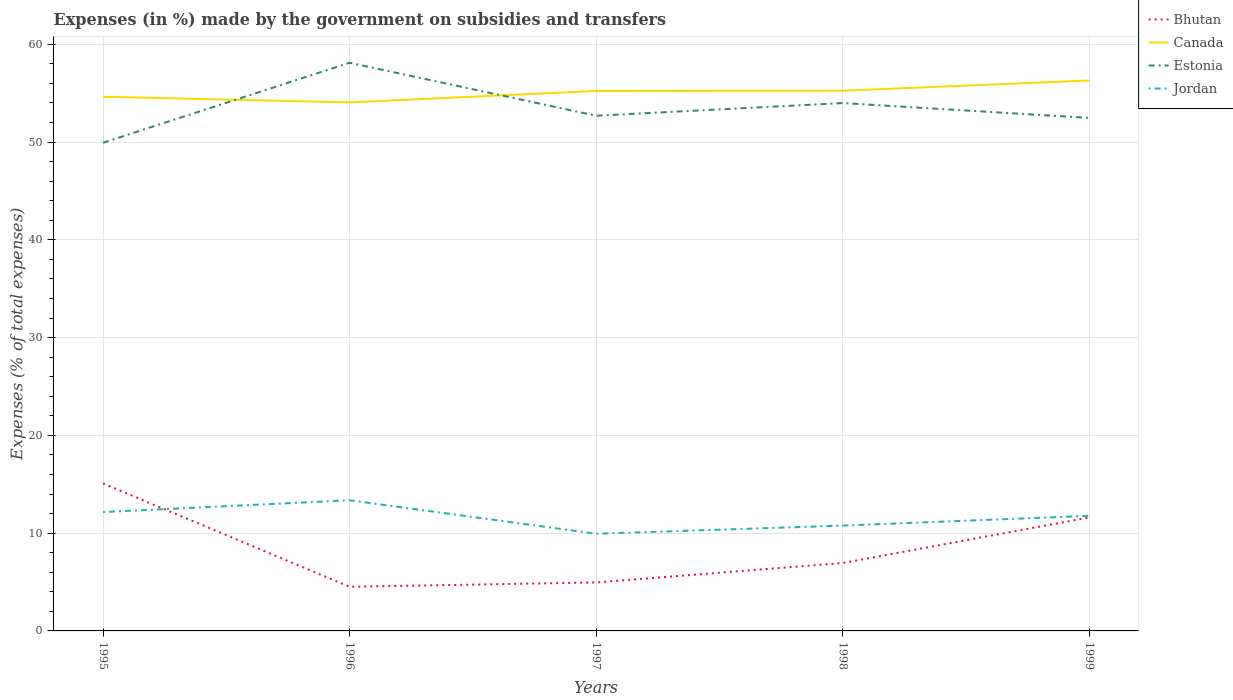How many different coloured lines are there?
Offer a very short reply. 4. Does the line corresponding to Canada intersect with the line corresponding to Bhutan?
Offer a very short reply. No. Is the number of lines equal to the number of legend labels?
Provide a short and direct response. Yes. Across all years, what is the maximum percentage of expenses made by the government on subsidies and transfers in Jordan?
Make the answer very short. 9.94. In which year was the percentage of expenses made by the government on subsidies and transfers in Estonia maximum?
Make the answer very short. 1995. What is the total percentage of expenses made by the government on subsidies and transfers in Canada in the graph?
Your response must be concise. 0.58. What is the difference between the highest and the second highest percentage of expenses made by the government on subsidies and transfers in Jordan?
Provide a short and direct response. 3.42. How many lines are there?
Make the answer very short. 4. How many years are there in the graph?
Your response must be concise. 5. What is the difference between two consecutive major ticks on the Y-axis?
Your answer should be very brief. 10. Does the graph contain any zero values?
Make the answer very short. No. Does the graph contain grids?
Make the answer very short. Yes. Where does the legend appear in the graph?
Your answer should be very brief. Top right. How many legend labels are there?
Give a very brief answer. 4. What is the title of the graph?
Your answer should be compact. Expenses (in %) made by the government on subsidies and transfers. Does "Cabo Verde" appear as one of the legend labels in the graph?
Your answer should be very brief. No. What is the label or title of the Y-axis?
Offer a very short reply. Expenses (% of total expenses). What is the Expenses (% of total expenses) in Bhutan in 1995?
Your response must be concise. 15.08. What is the Expenses (% of total expenses) of Canada in 1995?
Keep it short and to the point. 54.63. What is the Expenses (% of total expenses) in Estonia in 1995?
Ensure brevity in your answer.  49.93. What is the Expenses (% of total expenses) in Jordan in 1995?
Give a very brief answer. 12.16. What is the Expenses (% of total expenses) of Bhutan in 1996?
Keep it short and to the point. 4.51. What is the Expenses (% of total expenses) in Canada in 1996?
Give a very brief answer. 54.05. What is the Expenses (% of total expenses) of Estonia in 1996?
Provide a succinct answer. 58.11. What is the Expenses (% of total expenses) in Jordan in 1996?
Offer a very short reply. 13.36. What is the Expenses (% of total expenses) in Bhutan in 1997?
Your answer should be compact. 4.96. What is the Expenses (% of total expenses) in Canada in 1997?
Provide a succinct answer. 55.23. What is the Expenses (% of total expenses) of Estonia in 1997?
Give a very brief answer. 52.69. What is the Expenses (% of total expenses) of Jordan in 1997?
Provide a short and direct response. 9.94. What is the Expenses (% of total expenses) in Bhutan in 1998?
Provide a short and direct response. 6.95. What is the Expenses (% of total expenses) of Canada in 1998?
Make the answer very short. 55.25. What is the Expenses (% of total expenses) of Estonia in 1998?
Make the answer very short. 53.99. What is the Expenses (% of total expenses) of Jordan in 1998?
Ensure brevity in your answer.  10.77. What is the Expenses (% of total expenses) in Bhutan in 1999?
Offer a terse response. 11.61. What is the Expenses (% of total expenses) of Canada in 1999?
Provide a short and direct response. 56.29. What is the Expenses (% of total expenses) of Estonia in 1999?
Keep it short and to the point. 52.47. What is the Expenses (% of total expenses) in Jordan in 1999?
Your response must be concise. 11.77. Across all years, what is the maximum Expenses (% of total expenses) of Bhutan?
Provide a succinct answer. 15.08. Across all years, what is the maximum Expenses (% of total expenses) in Canada?
Provide a short and direct response. 56.29. Across all years, what is the maximum Expenses (% of total expenses) of Estonia?
Your answer should be very brief. 58.11. Across all years, what is the maximum Expenses (% of total expenses) of Jordan?
Your answer should be very brief. 13.36. Across all years, what is the minimum Expenses (% of total expenses) of Bhutan?
Give a very brief answer. 4.51. Across all years, what is the minimum Expenses (% of total expenses) of Canada?
Offer a very short reply. 54.05. Across all years, what is the minimum Expenses (% of total expenses) in Estonia?
Your answer should be compact. 49.93. Across all years, what is the minimum Expenses (% of total expenses) in Jordan?
Keep it short and to the point. 9.94. What is the total Expenses (% of total expenses) of Bhutan in the graph?
Provide a succinct answer. 43.11. What is the total Expenses (% of total expenses) of Canada in the graph?
Ensure brevity in your answer.  275.46. What is the total Expenses (% of total expenses) of Estonia in the graph?
Keep it short and to the point. 267.18. What is the total Expenses (% of total expenses) in Jordan in the graph?
Provide a succinct answer. 58. What is the difference between the Expenses (% of total expenses) in Bhutan in 1995 and that in 1996?
Offer a very short reply. 10.57. What is the difference between the Expenses (% of total expenses) of Canada in 1995 and that in 1996?
Offer a terse response. 0.58. What is the difference between the Expenses (% of total expenses) of Estonia in 1995 and that in 1996?
Offer a very short reply. -8.18. What is the difference between the Expenses (% of total expenses) in Jordan in 1995 and that in 1996?
Provide a short and direct response. -1.21. What is the difference between the Expenses (% of total expenses) of Bhutan in 1995 and that in 1997?
Provide a succinct answer. 10.12. What is the difference between the Expenses (% of total expenses) of Canada in 1995 and that in 1997?
Keep it short and to the point. -0.59. What is the difference between the Expenses (% of total expenses) in Estonia in 1995 and that in 1997?
Give a very brief answer. -2.76. What is the difference between the Expenses (% of total expenses) of Jordan in 1995 and that in 1997?
Provide a short and direct response. 2.22. What is the difference between the Expenses (% of total expenses) in Bhutan in 1995 and that in 1998?
Ensure brevity in your answer.  8.14. What is the difference between the Expenses (% of total expenses) of Canada in 1995 and that in 1998?
Your response must be concise. -0.62. What is the difference between the Expenses (% of total expenses) of Estonia in 1995 and that in 1998?
Your answer should be compact. -4.06. What is the difference between the Expenses (% of total expenses) of Jordan in 1995 and that in 1998?
Offer a very short reply. 1.38. What is the difference between the Expenses (% of total expenses) of Bhutan in 1995 and that in 1999?
Provide a succinct answer. 3.48. What is the difference between the Expenses (% of total expenses) in Canada in 1995 and that in 1999?
Your answer should be very brief. -1.66. What is the difference between the Expenses (% of total expenses) of Estonia in 1995 and that in 1999?
Offer a very short reply. -2.54. What is the difference between the Expenses (% of total expenses) in Jordan in 1995 and that in 1999?
Provide a short and direct response. 0.39. What is the difference between the Expenses (% of total expenses) of Bhutan in 1996 and that in 1997?
Provide a succinct answer. -0.44. What is the difference between the Expenses (% of total expenses) of Canada in 1996 and that in 1997?
Provide a succinct answer. -1.17. What is the difference between the Expenses (% of total expenses) in Estonia in 1996 and that in 1997?
Your response must be concise. 5.42. What is the difference between the Expenses (% of total expenses) in Jordan in 1996 and that in 1997?
Your response must be concise. 3.42. What is the difference between the Expenses (% of total expenses) in Bhutan in 1996 and that in 1998?
Keep it short and to the point. -2.43. What is the difference between the Expenses (% of total expenses) of Canada in 1996 and that in 1998?
Provide a short and direct response. -1.2. What is the difference between the Expenses (% of total expenses) in Estonia in 1996 and that in 1998?
Make the answer very short. 4.12. What is the difference between the Expenses (% of total expenses) of Jordan in 1996 and that in 1998?
Offer a very short reply. 2.59. What is the difference between the Expenses (% of total expenses) of Bhutan in 1996 and that in 1999?
Make the answer very short. -7.09. What is the difference between the Expenses (% of total expenses) in Canada in 1996 and that in 1999?
Keep it short and to the point. -2.24. What is the difference between the Expenses (% of total expenses) of Estonia in 1996 and that in 1999?
Provide a short and direct response. 5.64. What is the difference between the Expenses (% of total expenses) in Jordan in 1996 and that in 1999?
Offer a very short reply. 1.59. What is the difference between the Expenses (% of total expenses) of Bhutan in 1997 and that in 1998?
Your answer should be compact. -1.99. What is the difference between the Expenses (% of total expenses) of Canada in 1997 and that in 1998?
Offer a very short reply. -0.02. What is the difference between the Expenses (% of total expenses) in Estonia in 1997 and that in 1998?
Keep it short and to the point. -1.3. What is the difference between the Expenses (% of total expenses) of Jordan in 1997 and that in 1998?
Offer a terse response. -0.83. What is the difference between the Expenses (% of total expenses) in Bhutan in 1997 and that in 1999?
Offer a very short reply. -6.65. What is the difference between the Expenses (% of total expenses) of Canada in 1997 and that in 1999?
Keep it short and to the point. -1.07. What is the difference between the Expenses (% of total expenses) in Estonia in 1997 and that in 1999?
Your answer should be compact. 0.22. What is the difference between the Expenses (% of total expenses) of Jordan in 1997 and that in 1999?
Make the answer very short. -1.83. What is the difference between the Expenses (% of total expenses) in Bhutan in 1998 and that in 1999?
Ensure brevity in your answer.  -4.66. What is the difference between the Expenses (% of total expenses) in Canada in 1998 and that in 1999?
Provide a short and direct response. -1.04. What is the difference between the Expenses (% of total expenses) of Estonia in 1998 and that in 1999?
Ensure brevity in your answer.  1.52. What is the difference between the Expenses (% of total expenses) of Jordan in 1998 and that in 1999?
Keep it short and to the point. -1. What is the difference between the Expenses (% of total expenses) of Bhutan in 1995 and the Expenses (% of total expenses) of Canada in 1996?
Your answer should be very brief. -38.97. What is the difference between the Expenses (% of total expenses) of Bhutan in 1995 and the Expenses (% of total expenses) of Estonia in 1996?
Make the answer very short. -43.03. What is the difference between the Expenses (% of total expenses) in Bhutan in 1995 and the Expenses (% of total expenses) in Jordan in 1996?
Give a very brief answer. 1.72. What is the difference between the Expenses (% of total expenses) of Canada in 1995 and the Expenses (% of total expenses) of Estonia in 1996?
Your response must be concise. -3.47. What is the difference between the Expenses (% of total expenses) in Canada in 1995 and the Expenses (% of total expenses) in Jordan in 1996?
Your answer should be compact. 41.27. What is the difference between the Expenses (% of total expenses) in Estonia in 1995 and the Expenses (% of total expenses) in Jordan in 1996?
Your response must be concise. 36.57. What is the difference between the Expenses (% of total expenses) in Bhutan in 1995 and the Expenses (% of total expenses) in Canada in 1997?
Offer a terse response. -40.14. What is the difference between the Expenses (% of total expenses) of Bhutan in 1995 and the Expenses (% of total expenses) of Estonia in 1997?
Your answer should be very brief. -37.61. What is the difference between the Expenses (% of total expenses) in Bhutan in 1995 and the Expenses (% of total expenses) in Jordan in 1997?
Your response must be concise. 5.14. What is the difference between the Expenses (% of total expenses) in Canada in 1995 and the Expenses (% of total expenses) in Estonia in 1997?
Provide a short and direct response. 1.94. What is the difference between the Expenses (% of total expenses) in Canada in 1995 and the Expenses (% of total expenses) in Jordan in 1997?
Offer a very short reply. 44.69. What is the difference between the Expenses (% of total expenses) of Estonia in 1995 and the Expenses (% of total expenses) of Jordan in 1997?
Your answer should be very brief. 39.99. What is the difference between the Expenses (% of total expenses) in Bhutan in 1995 and the Expenses (% of total expenses) in Canada in 1998?
Provide a succinct answer. -40.17. What is the difference between the Expenses (% of total expenses) in Bhutan in 1995 and the Expenses (% of total expenses) in Estonia in 1998?
Offer a very short reply. -38.9. What is the difference between the Expenses (% of total expenses) of Bhutan in 1995 and the Expenses (% of total expenses) of Jordan in 1998?
Provide a succinct answer. 4.31. What is the difference between the Expenses (% of total expenses) of Canada in 1995 and the Expenses (% of total expenses) of Estonia in 1998?
Your answer should be very brief. 0.65. What is the difference between the Expenses (% of total expenses) of Canada in 1995 and the Expenses (% of total expenses) of Jordan in 1998?
Provide a succinct answer. 43.86. What is the difference between the Expenses (% of total expenses) in Estonia in 1995 and the Expenses (% of total expenses) in Jordan in 1998?
Ensure brevity in your answer.  39.16. What is the difference between the Expenses (% of total expenses) in Bhutan in 1995 and the Expenses (% of total expenses) in Canada in 1999?
Give a very brief answer. -41.21. What is the difference between the Expenses (% of total expenses) in Bhutan in 1995 and the Expenses (% of total expenses) in Estonia in 1999?
Your answer should be compact. -37.38. What is the difference between the Expenses (% of total expenses) in Bhutan in 1995 and the Expenses (% of total expenses) in Jordan in 1999?
Keep it short and to the point. 3.31. What is the difference between the Expenses (% of total expenses) of Canada in 1995 and the Expenses (% of total expenses) of Estonia in 1999?
Provide a succinct answer. 2.17. What is the difference between the Expenses (% of total expenses) of Canada in 1995 and the Expenses (% of total expenses) of Jordan in 1999?
Your response must be concise. 42.86. What is the difference between the Expenses (% of total expenses) in Estonia in 1995 and the Expenses (% of total expenses) in Jordan in 1999?
Your answer should be compact. 38.16. What is the difference between the Expenses (% of total expenses) in Bhutan in 1996 and the Expenses (% of total expenses) in Canada in 1997?
Give a very brief answer. -50.71. What is the difference between the Expenses (% of total expenses) in Bhutan in 1996 and the Expenses (% of total expenses) in Estonia in 1997?
Your answer should be compact. -48.18. What is the difference between the Expenses (% of total expenses) in Bhutan in 1996 and the Expenses (% of total expenses) in Jordan in 1997?
Make the answer very short. -5.43. What is the difference between the Expenses (% of total expenses) of Canada in 1996 and the Expenses (% of total expenses) of Estonia in 1997?
Provide a short and direct response. 1.36. What is the difference between the Expenses (% of total expenses) in Canada in 1996 and the Expenses (% of total expenses) in Jordan in 1997?
Your answer should be very brief. 44.11. What is the difference between the Expenses (% of total expenses) in Estonia in 1996 and the Expenses (% of total expenses) in Jordan in 1997?
Your answer should be compact. 48.17. What is the difference between the Expenses (% of total expenses) of Bhutan in 1996 and the Expenses (% of total expenses) of Canada in 1998?
Offer a terse response. -50.74. What is the difference between the Expenses (% of total expenses) of Bhutan in 1996 and the Expenses (% of total expenses) of Estonia in 1998?
Offer a very short reply. -49.47. What is the difference between the Expenses (% of total expenses) in Bhutan in 1996 and the Expenses (% of total expenses) in Jordan in 1998?
Your response must be concise. -6.26. What is the difference between the Expenses (% of total expenses) in Canada in 1996 and the Expenses (% of total expenses) in Estonia in 1998?
Your answer should be very brief. 0.07. What is the difference between the Expenses (% of total expenses) of Canada in 1996 and the Expenses (% of total expenses) of Jordan in 1998?
Your response must be concise. 43.28. What is the difference between the Expenses (% of total expenses) in Estonia in 1996 and the Expenses (% of total expenses) in Jordan in 1998?
Provide a short and direct response. 47.34. What is the difference between the Expenses (% of total expenses) of Bhutan in 1996 and the Expenses (% of total expenses) of Canada in 1999?
Keep it short and to the point. -51.78. What is the difference between the Expenses (% of total expenses) of Bhutan in 1996 and the Expenses (% of total expenses) of Estonia in 1999?
Your answer should be very brief. -47.95. What is the difference between the Expenses (% of total expenses) in Bhutan in 1996 and the Expenses (% of total expenses) in Jordan in 1999?
Keep it short and to the point. -7.26. What is the difference between the Expenses (% of total expenses) of Canada in 1996 and the Expenses (% of total expenses) of Estonia in 1999?
Ensure brevity in your answer.  1.59. What is the difference between the Expenses (% of total expenses) in Canada in 1996 and the Expenses (% of total expenses) in Jordan in 1999?
Your response must be concise. 42.28. What is the difference between the Expenses (% of total expenses) of Estonia in 1996 and the Expenses (% of total expenses) of Jordan in 1999?
Your answer should be very brief. 46.34. What is the difference between the Expenses (% of total expenses) of Bhutan in 1997 and the Expenses (% of total expenses) of Canada in 1998?
Offer a terse response. -50.29. What is the difference between the Expenses (% of total expenses) in Bhutan in 1997 and the Expenses (% of total expenses) in Estonia in 1998?
Offer a very short reply. -49.03. What is the difference between the Expenses (% of total expenses) in Bhutan in 1997 and the Expenses (% of total expenses) in Jordan in 1998?
Your response must be concise. -5.81. What is the difference between the Expenses (% of total expenses) in Canada in 1997 and the Expenses (% of total expenses) in Estonia in 1998?
Give a very brief answer. 1.24. What is the difference between the Expenses (% of total expenses) in Canada in 1997 and the Expenses (% of total expenses) in Jordan in 1998?
Make the answer very short. 44.45. What is the difference between the Expenses (% of total expenses) in Estonia in 1997 and the Expenses (% of total expenses) in Jordan in 1998?
Make the answer very short. 41.92. What is the difference between the Expenses (% of total expenses) of Bhutan in 1997 and the Expenses (% of total expenses) of Canada in 1999?
Provide a short and direct response. -51.33. What is the difference between the Expenses (% of total expenses) in Bhutan in 1997 and the Expenses (% of total expenses) in Estonia in 1999?
Your answer should be very brief. -47.51. What is the difference between the Expenses (% of total expenses) of Bhutan in 1997 and the Expenses (% of total expenses) of Jordan in 1999?
Your answer should be compact. -6.81. What is the difference between the Expenses (% of total expenses) of Canada in 1997 and the Expenses (% of total expenses) of Estonia in 1999?
Your answer should be very brief. 2.76. What is the difference between the Expenses (% of total expenses) of Canada in 1997 and the Expenses (% of total expenses) of Jordan in 1999?
Ensure brevity in your answer.  43.46. What is the difference between the Expenses (% of total expenses) of Estonia in 1997 and the Expenses (% of total expenses) of Jordan in 1999?
Provide a succinct answer. 40.92. What is the difference between the Expenses (% of total expenses) in Bhutan in 1998 and the Expenses (% of total expenses) in Canada in 1999?
Your response must be concise. -49.35. What is the difference between the Expenses (% of total expenses) of Bhutan in 1998 and the Expenses (% of total expenses) of Estonia in 1999?
Keep it short and to the point. -45.52. What is the difference between the Expenses (% of total expenses) in Bhutan in 1998 and the Expenses (% of total expenses) in Jordan in 1999?
Make the answer very short. -4.82. What is the difference between the Expenses (% of total expenses) in Canada in 1998 and the Expenses (% of total expenses) in Estonia in 1999?
Provide a short and direct response. 2.78. What is the difference between the Expenses (% of total expenses) in Canada in 1998 and the Expenses (% of total expenses) in Jordan in 1999?
Offer a terse response. 43.48. What is the difference between the Expenses (% of total expenses) in Estonia in 1998 and the Expenses (% of total expenses) in Jordan in 1999?
Offer a very short reply. 42.22. What is the average Expenses (% of total expenses) of Bhutan per year?
Keep it short and to the point. 8.62. What is the average Expenses (% of total expenses) in Canada per year?
Ensure brevity in your answer.  55.09. What is the average Expenses (% of total expenses) of Estonia per year?
Provide a succinct answer. 53.44. What is the average Expenses (% of total expenses) in Jordan per year?
Make the answer very short. 11.6. In the year 1995, what is the difference between the Expenses (% of total expenses) of Bhutan and Expenses (% of total expenses) of Canada?
Offer a very short reply. -39.55. In the year 1995, what is the difference between the Expenses (% of total expenses) of Bhutan and Expenses (% of total expenses) of Estonia?
Give a very brief answer. -34.85. In the year 1995, what is the difference between the Expenses (% of total expenses) in Bhutan and Expenses (% of total expenses) in Jordan?
Keep it short and to the point. 2.93. In the year 1995, what is the difference between the Expenses (% of total expenses) in Canada and Expenses (% of total expenses) in Estonia?
Give a very brief answer. 4.71. In the year 1995, what is the difference between the Expenses (% of total expenses) in Canada and Expenses (% of total expenses) in Jordan?
Your answer should be compact. 42.48. In the year 1995, what is the difference between the Expenses (% of total expenses) in Estonia and Expenses (% of total expenses) in Jordan?
Your response must be concise. 37.77. In the year 1996, what is the difference between the Expenses (% of total expenses) in Bhutan and Expenses (% of total expenses) in Canada?
Make the answer very short. -49.54. In the year 1996, what is the difference between the Expenses (% of total expenses) of Bhutan and Expenses (% of total expenses) of Estonia?
Offer a very short reply. -53.59. In the year 1996, what is the difference between the Expenses (% of total expenses) of Bhutan and Expenses (% of total expenses) of Jordan?
Offer a very short reply. -8.85. In the year 1996, what is the difference between the Expenses (% of total expenses) in Canada and Expenses (% of total expenses) in Estonia?
Offer a terse response. -4.05. In the year 1996, what is the difference between the Expenses (% of total expenses) of Canada and Expenses (% of total expenses) of Jordan?
Make the answer very short. 40.69. In the year 1996, what is the difference between the Expenses (% of total expenses) of Estonia and Expenses (% of total expenses) of Jordan?
Your answer should be very brief. 44.74. In the year 1997, what is the difference between the Expenses (% of total expenses) in Bhutan and Expenses (% of total expenses) in Canada?
Ensure brevity in your answer.  -50.27. In the year 1997, what is the difference between the Expenses (% of total expenses) in Bhutan and Expenses (% of total expenses) in Estonia?
Your response must be concise. -47.73. In the year 1997, what is the difference between the Expenses (% of total expenses) in Bhutan and Expenses (% of total expenses) in Jordan?
Your answer should be compact. -4.98. In the year 1997, what is the difference between the Expenses (% of total expenses) of Canada and Expenses (% of total expenses) of Estonia?
Offer a terse response. 2.53. In the year 1997, what is the difference between the Expenses (% of total expenses) of Canada and Expenses (% of total expenses) of Jordan?
Make the answer very short. 45.29. In the year 1997, what is the difference between the Expenses (% of total expenses) of Estonia and Expenses (% of total expenses) of Jordan?
Your answer should be very brief. 42.75. In the year 1998, what is the difference between the Expenses (% of total expenses) in Bhutan and Expenses (% of total expenses) in Canada?
Your response must be concise. -48.3. In the year 1998, what is the difference between the Expenses (% of total expenses) in Bhutan and Expenses (% of total expenses) in Estonia?
Keep it short and to the point. -47.04. In the year 1998, what is the difference between the Expenses (% of total expenses) of Bhutan and Expenses (% of total expenses) of Jordan?
Ensure brevity in your answer.  -3.83. In the year 1998, what is the difference between the Expenses (% of total expenses) in Canada and Expenses (% of total expenses) in Estonia?
Give a very brief answer. 1.26. In the year 1998, what is the difference between the Expenses (% of total expenses) of Canada and Expenses (% of total expenses) of Jordan?
Your answer should be very brief. 44.48. In the year 1998, what is the difference between the Expenses (% of total expenses) in Estonia and Expenses (% of total expenses) in Jordan?
Make the answer very short. 43.21. In the year 1999, what is the difference between the Expenses (% of total expenses) in Bhutan and Expenses (% of total expenses) in Canada?
Your answer should be compact. -44.69. In the year 1999, what is the difference between the Expenses (% of total expenses) of Bhutan and Expenses (% of total expenses) of Estonia?
Your answer should be very brief. -40.86. In the year 1999, what is the difference between the Expenses (% of total expenses) of Bhutan and Expenses (% of total expenses) of Jordan?
Provide a succinct answer. -0.16. In the year 1999, what is the difference between the Expenses (% of total expenses) in Canada and Expenses (% of total expenses) in Estonia?
Ensure brevity in your answer.  3.83. In the year 1999, what is the difference between the Expenses (% of total expenses) of Canada and Expenses (% of total expenses) of Jordan?
Your answer should be compact. 44.52. In the year 1999, what is the difference between the Expenses (% of total expenses) in Estonia and Expenses (% of total expenses) in Jordan?
Keep it short and to the point. 40.7. What is the ratio of the Expenses (% of total expenses) in Bhutan in 1995 to that in 1996?
Offer a very short reply. 3.34. What is the ratio of the Expenses (% of total expenses) of Canada in 1995 to that in 1996?
Your answer should be compact. 1.01. What is the ratio of the Expenses (% of total expenses) in Estonia in 1995 to that in 1996?
Your answer should be compact. 0.86. What is the ratio of the Expenses (% of total expenses) of Jordan in 1995 to that in 1996?
Keep it short and to the point. 0.91. What is the ratio of the Expenses (% of total expenses) in Bhutan in 1995 to that in 1997?
Your answer should be compact. 3.04. What is the ratio of the Expenses (% of total expenses) in Canada in 1995 to that in 1997?
Give a very brief answer. 0.99. What is the ratio of the Expenses (% of total expenses) in Estonia in 1995 to that in 1997?
Ensure brevity in your answer.  0.95. What is the ratio of the Expenses (% of total expenses) in Jordan in 1995 to that in 1997?
Your answer should be very brief. 1.22. What is the ratio of the Expenses (% of total expenses) in Bhutan in 1995 to that in 1998?
Keep it short and to the point. 2.17. What is the ratio of the Expenses (% of total expenses) in Canada in 1995 to that in 1998?
Your answer should be compact. 0.99. What is the ratio of the Expenses (% of total expenses) in Estonia in 1995 to that in 1998?
Your answer should be very brief. 0.92. What is the ratio of the Expenses (% of total expenses) in Jordan in 1995 to that in 1998?
Ensure brevity in your answer.  1.13. What is the ratio of the Expenses (% of total expenses) in Bhutan in 1995 to that in 1999?
Provide a succinct answer. 1.3. What is the ratio of the Expenses (% of total expenses) in Canada in 1995 to that in 1999?
Your answer should be compact. 0.97. What is the ratio of the Expenses (% of total expenses) in Estonia in 1995 to that in 1999?
Offer a terse response. 0.95. What is the ratio of the Expenses (% of total expenses) of Jordan in 1995 to that in 1999?
Provide a succinct answer. 1.03. What is the ratio of the Expenses (% of total expenses) of Bhutan in 1996 to that in 1997?
Make the answer very short. 0.91. What is the ratio of the Expenses (% of total expenses) of Canada in 1996 to that in 1997?
Give a very brief answer. 0.98. What is the ratio of the Expenses (% of total expenses) in Estonia in 1996 to that in 1997?
Your answer should be very brief. 1.1. What is the ratio of the Expenses (% of total expenses) of Jordan in 1996 to that in 1997?
Give a very brief answer. 1.34. What is the ratio of the Expenses (% of total expenses) in Bhutan in 1996 to that in 1998?
Ensure brevity in your answer.  0.65. What is the ratio of the Expenses (% of total expenses) of Canada in 1996 to that in 1998?
Offer a terse response. 0.98. What is the ratio of the Expenses (% of total expenses) in Estonia in 1996 to that in 1998?
Offer a terse response. 1.08. What is the ratio of the Expenses (% of total expenses) of Jordan in 1996 to that in 1998?
Your response must be concise. 1.24. What is the ratio of the Expenses (% of total expenses) in Bhutan in 1996 to that in 1999?
Provide a succinct answer. 0.39. What is the ratio of the Expenses (% of total expenses) in Canada in 1996 to that in 1999?
Your answer should be compact. 0.96. What is the ratio of the Expenses (% of total expenses) of Estonia in 1996 to that in 1999?
Give a very brief answer. 1.11. What is the ratio of the Expenses (% of total expenses) of Jordan in 1996 to that in 1999?
Keep it short and to the point. 1.14. What is the ratio of the Expenses (% of total expenses) of Bhutan in 1997 to that in 1998?
Offer a terse response. 0.71. What is the ratio of the Expenses (% of total expenses) of Canada in 1997 to that in 1998?
Keep it short and to the point. 1. What is the ratio of the Expenses (% of total expenses) of Estonia in 1997 to that in 1998?
Offer a very short reply. 0.98. What is the ratio of the Expenses (% of total expenses) in Jordan in 1997 to that in 1998?
Your answer should be compact. 0.92. What is the ratio of the Expenses (% of total expenses) in Bhutan in 1997 to that in 1999?
Your response must be concise. 0.43. What is the ratio of the Expenses (% of total expenses) of Canada in 1997 to that in 1999?
Keep it short and to the point. 0.98. What is the ratio of the Expenses (% of total expenses) in Estonia in 1997 to that in 1999?
Your response must be concise. 1. What is the ratio of the Expenses (% of total expenses) in Jordan in 1997 to that in 1999?
Give a very brief answer. 0.84. What is the ratio of the Expenses (% of total expenses) of Bhutan in 1998 to that in 1999?
Offer a very short reply. 0.6. What is the ratio of the Expenses (% of total expenses) of Canada in 1998 to that in 1999?
Give a very brief answer. 0.98. What is the ratio of the Expenses (% of total expenses) of Estonia in 1998 to that in 1999?
Offer a very short reply. 1.03. What is the ratio of the Expenses (% of total expenses) of Jordan in 1998 to that in 1999?
Ensure brevity in your answer.  0.92. What is the difference between the highest and the second highest Expenses (% of total expenses) in Bhutan?
Ensure brevity in your answer.  3.48. What is the difference between the highest and the second highest Expenses (% of total expenses) of Canada?
Offer a very short reply. 1.04. What is the difference between the highest and the second highest Expenses (% of total expenses) in Estonia?
Provide a succinct answer. 4.12. What is the difference between the highest and the second highest Expenses (% of total expenses) of Jordan?
Offer a very short reply. 1.21. What is the difference between the highest and the lowest Expenses (% of total expenses) of Bhutan?
Your answer should be very brief. 10.57. What is the difference between the highest and the lowest Expenses (% of total expenses) of Canada?
Ensure brevity in your answer.  2.24. What is the difference between the highest and the lowest Expenses (% of total expenses) in Estonia?
Your response must be concise. 8.18. What is the difference between the highest and the lowest Expenses (% of total expenses) of Jordan?
Keep it short and to the point. 3.42. 